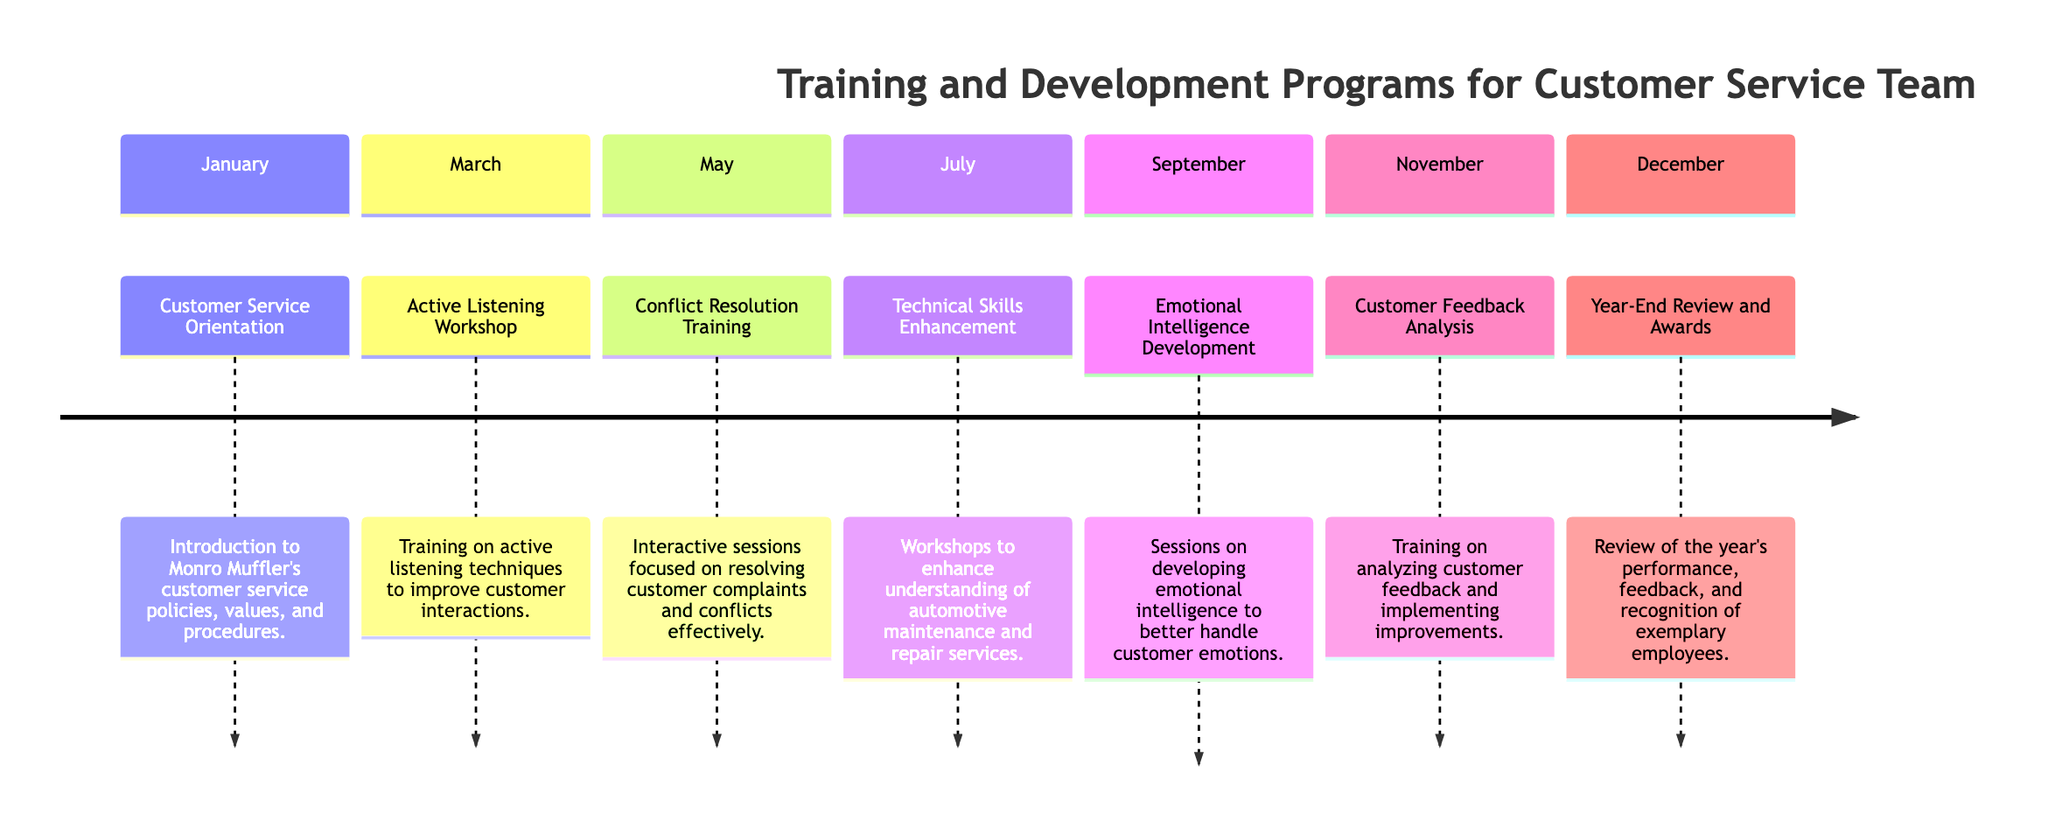What event happens in January? The January section lists "Customer Service Orientation," which is the event that occurs prominently displayed in that month.
Answer: Customer Service Orientation How many days is the Conflict Resolution Training? The description for "Conflict Resolution Training" in May states that it lasts for "3 Days". Thus, we can derive the duration directly from that piece of information.
Answer: 3 Days Which program is conducted in July? Referring to the July section of the timeline, it mentions "Technical Skills Enhancement" as the program scheduled for that month.
Answer: Technical Skills Enhancement What is the main focus of the Emotional Intelligence Development sessions? The description in the September section states that the focus is on developing emotional intelligence to better handle customer emotions. This makes it clear what the emphasis of that training is.
Answer: Developing emotional intelligence Which month has the longest training duration? Comparing durations across all sections, we see that "Technical Skills Enhancement" in July lasts 4 Days, which is longer than any other training. Therefore, that indicates it is the longest duration.
Answer: 4 Days What is the location for the Customer Feedback Analysis training? The "Customer Feedback Analysis" event mentioned in November clearly states that it takes place at the "Head Office." This gives us the answer regarding its location.
Answer: Head Office How many training programs occur before September? By counting the events listed from January to September, we find January, March, May, and July gives us a total of 5 programs. So, we can ascertain that there are 5 programs before September.
Answer: 5 Which event is held in December? The December section of the timeline specifies that the event is "Year-End Review and Awards," making it clear what occurs in that month.
Answer: Year-End Review and Awards What type of training is emphasized in March? The March section indicates a focus on "Active Listening Workshop," implying that the type of training emphasized is active listening techniques for customer interactions.
Answer: Active listening techniques 